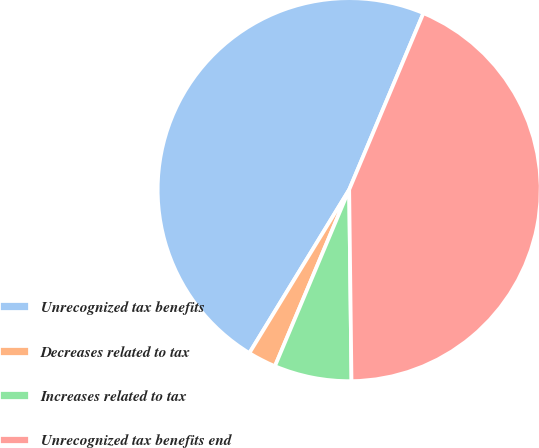Convert chart. <chart><loc_0><loc_0><loc_500><loc_500><pie_chart><fcel>Unrecognized tax benefits<fcel>Decreases related to tax<fcel>Increases related to tax<fcel>Unrecognized tax benefits end<nl><fcel>47.61%<fcel>2.39%<fcel>6.53%<fcel>43.47%<nl></chart> 